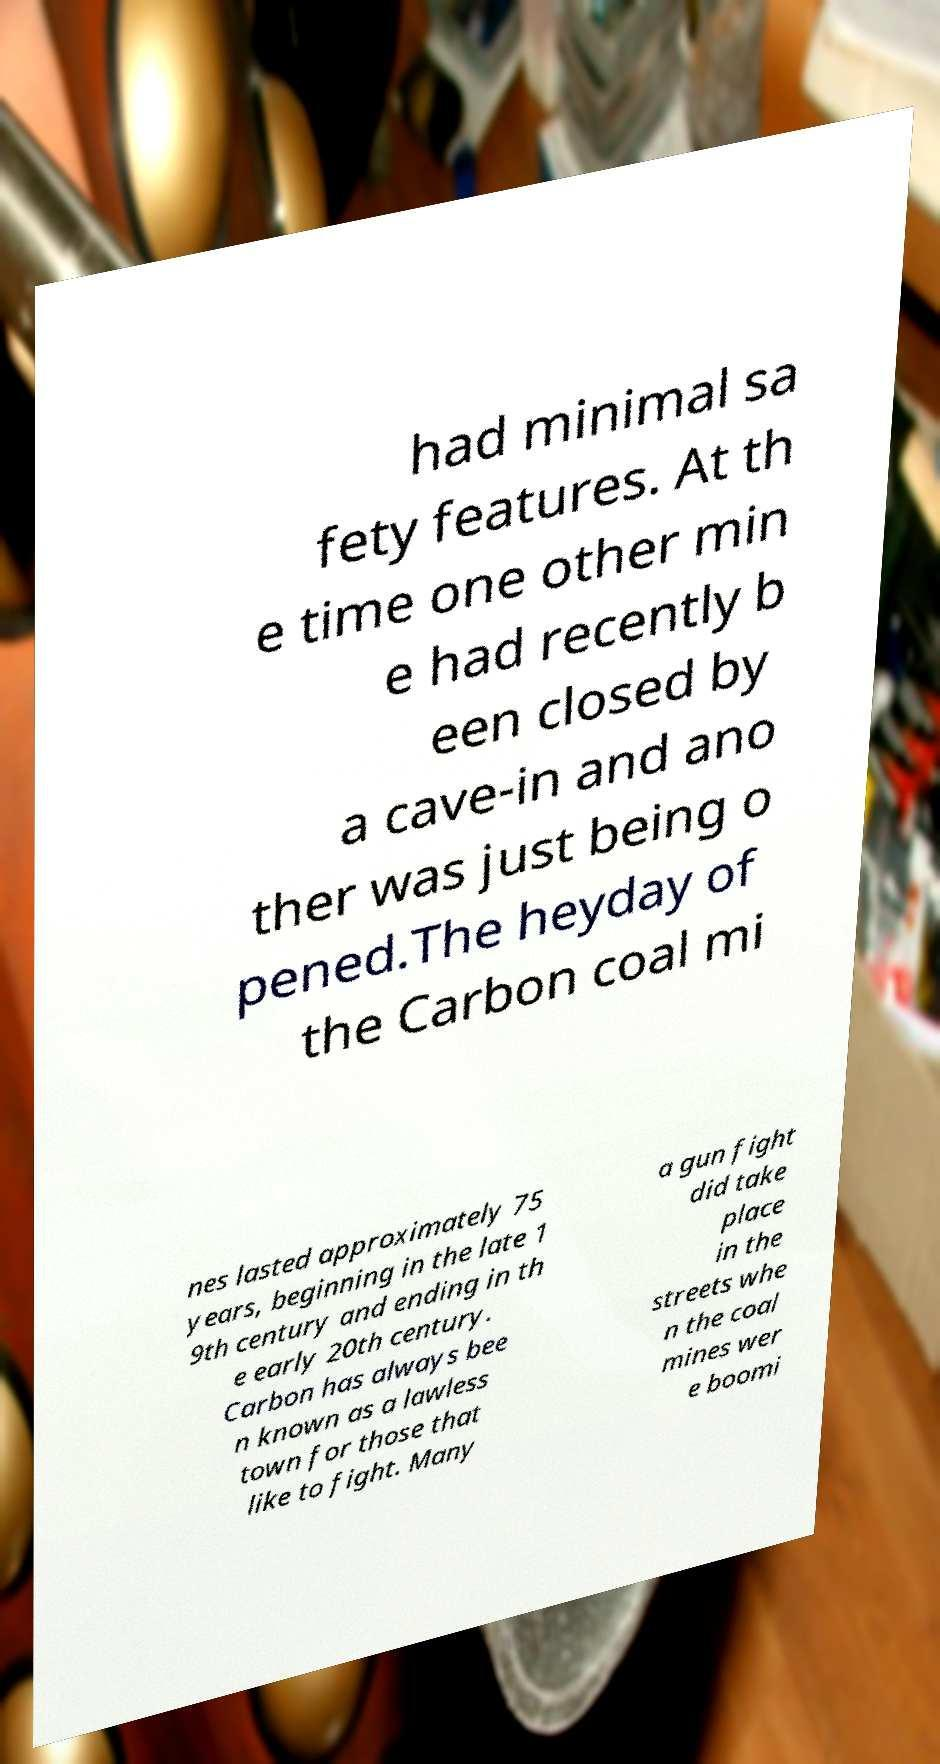What messages or text are displayed in this image? I need them in a readable, typed format. had minimal sa fety features. At th e time one other min e had recently b een closed by a cave-in and ano ther was just being o pened.The heyday of the Carbon coal mi nes lasted approximately 75 years, beginning in the late 1 9th century and ending in th e early 20th century. Carbon has always bee n known as a lawless town for those that like to fight. Many a gun fight did take place in the streets whe n the coal mines wer e boomi 